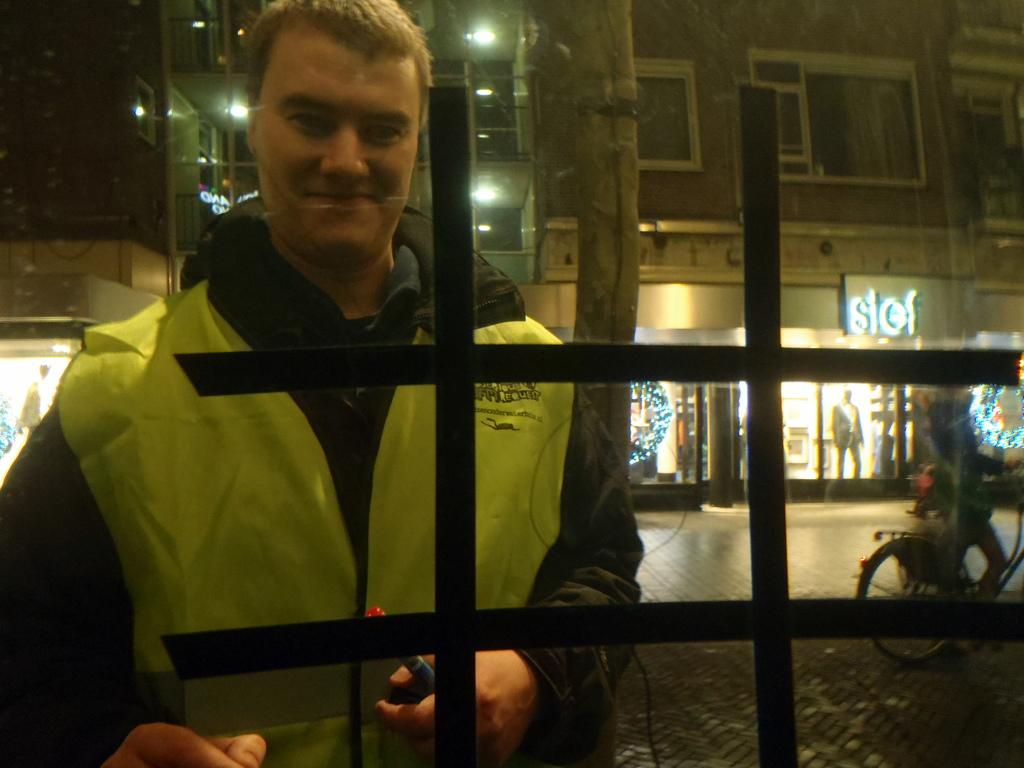What is the main subject of the image? There is a person standing in the image. What is the person wearing? The person is wearing a jacket. What can be seen in the background of the image? Buildings, windows, stores, lights, and a bicycle on the road are visible in the background. How many beds can be seen in the image? There are no beds present in the image. 